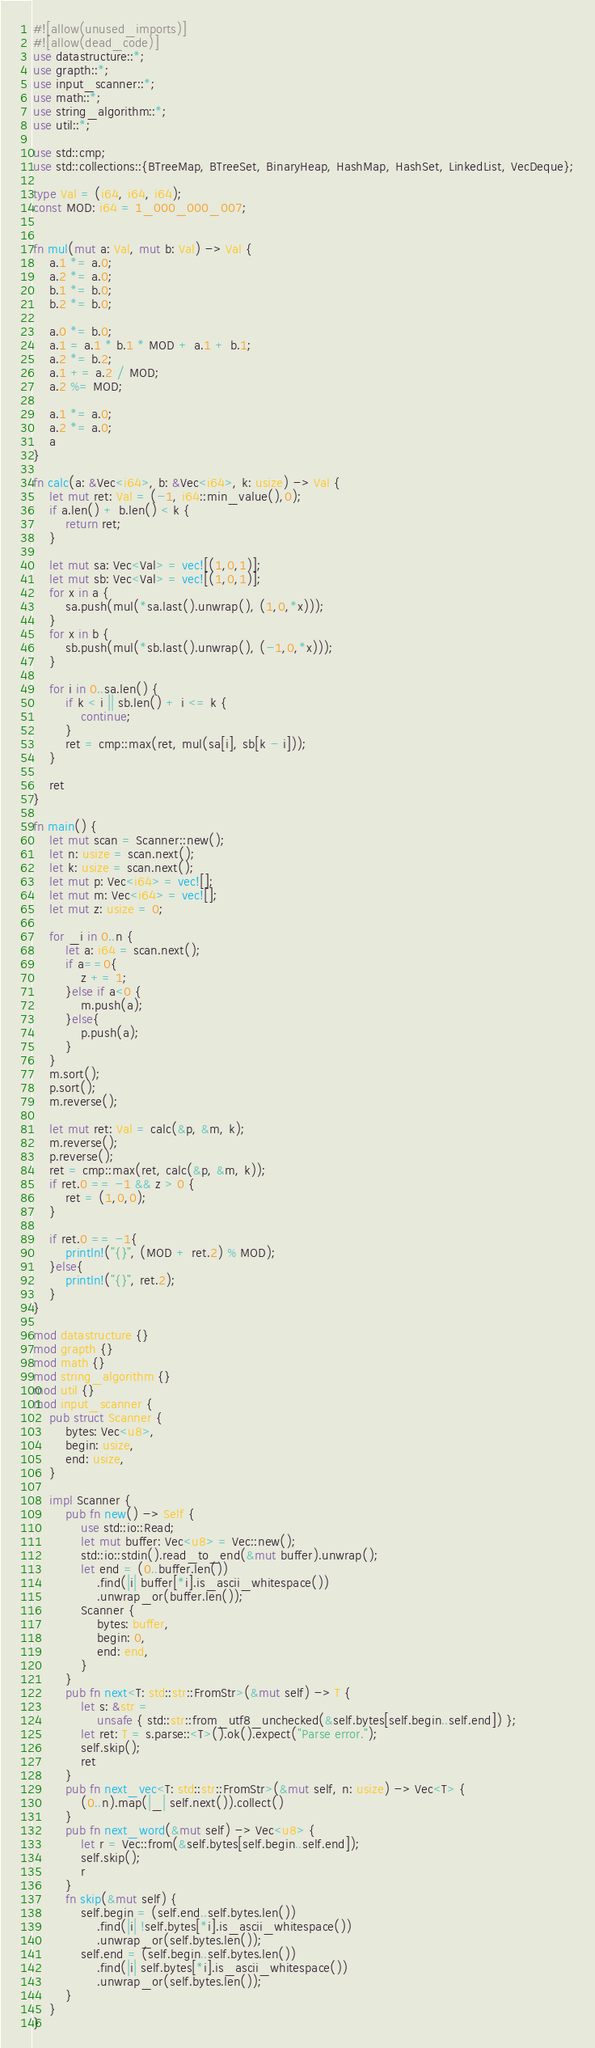Convert code to text. <code><loc_0><loc_0><loc_500><loc_500><_Rust_>#![allow(unused_imports)]
#![allow(dead_code)]
use datastructure::*;
use grapth::*;
use input_scanner::*;
use math::*;
use string_algorithm::*;
use util::*;

use std::cmp;
use std::collections::{BTreeMap, BTreeSet, BinaryHeap, HashMap, HashSet, LinkedList, VecDeque};

type Val = (i64, i64, i64);
const MOD: i64 = 1_000_000_007;


fn mul(mut a: Val, mut b: Val) -> Val {
    a.1 *= a.0;
    a.2 *= a.0;
    b.1 *= b.0;
    b.2 *= b.0;

    a.0 *= b.0;
    a.1 = a.1 * b.1 * MOD + a.1 + b.1;
    a.2 *= b.2;
    a.1 += a.2 / MOD;
    a.2 %= MOD;

    a.1 *= a.0;
    a.2 *= a.0;
    a
}

fn calc(a: &Vec<i64>, b: &Vec<i64>, k: usize) -> Val {
    let mut ret: Val = (-1, i64::min_value(),0);
    if a.len() + b.len() < k {
        return ret;
    }

    let mut sa: Vec<Val> = vec![(1,0,1)];
    let mut sb: Vec<Val> = vec![(1,0,1)];
    for x in a {
        sa.push(mul(*sa.last().unwrap(), (1,0,*x)));
    }
    for x in b {
        sb.push(mul(*sb.last().unwrap(), (-1,0,*x)));
    }

    for i in 0..sa.len() {
        if k < i || sb.len() + i <= k {
            continue;
        }
        ret = cmp::max(ret, mul(sa[i], sb[k - i]));
    }

    ret
}

fn main() {
    let mut scan = Scanner::new();
    let n: usize = scan.next();
    let k: usize = scan.next();
    let mut p: Vec<i64> = vec![];
    let mut m: Vec<i64> = vec![];
    let mut z: usize = 0;
    
    for _i in 0..n {
        let a: i64 = scan.next();
        if a==0{
            z += 1;
        }else if a<0 {
            m.push(a);
        }else{
            p.push(a);
        }
    }
    m.sort();
    p.sort();
    m.reverse();

    let mut ret: Val = calc(&p, &m, k);
    m.reverse();
    p.reverse();
    ret = cmp::max(ret, calc(&p, &m, k));
    if ret.0 == -1 && z > 0 {
        ret = (1,0,0);
    }

    if ret.0 == -1{
        println!("{}", (MOD + ret.2) % MOD);
    }else{
        println!("{}", ret.2);
    }
}

mod datastructure {}
mod grapth {}
mod math {}
mod string_algorithm {}
mod util {}
mod input_scanner {
    pub struct Scanner {
        bytes: Vec<u8>,
        begin: usize,
        end: usize,
    }

    impl Scanner {
        pub fn new() -> Self {
            use std::io::Read;
            let mut buffer: Vec<u8> = Vec::new();
            std::io::stdin().read_to_end(&mut buffer).unwrap();
            let end = (0..buffer.len())
                .find(|i| buffer[*i].is_ascii_whitespace())
                .unwrap_or(buffer.len());
            Scanner {
                bytes: buffer,
                begin: 0,
                end: end,
            }
        }
        pub fn next<T: std::str::FromStr>(&mut self) -> T {
            let s: &str =
                unsafe { std::str::from_utf8_unchecked(&self.bytes[self.begin..self.end]) };
            let ret: T = s.parse::<T>().ok().expect("Parse error.");
            self.skip();
            ret
        }
        pub fn next_vec<T: std::str::FromStr>(&mut self, n: usize) -> Vec<T> {
            (0..n).map(|_| self.next()).collect()
        }
        pub fn next_word(&mut self) -> Vec<u8> {
            let r = Vec::from(&self.bytes[self.begin..self.end]);
            self.skip();
            r
        }
        fn skip(&mut self) {
            self.begin = (self.end..self.bytes.len())
                .find(|i| !self.bytes[*i].is_ascii_whitespace())
                .unwrap_or(self.bytes.len());
            self.end = (self.begin..self.bytes.len())
                .find(|i| self.bytes[*i].is_ascii_whitespace())
                .unwrap_or(self.bytes.len());
        }
    }
}
</code> 